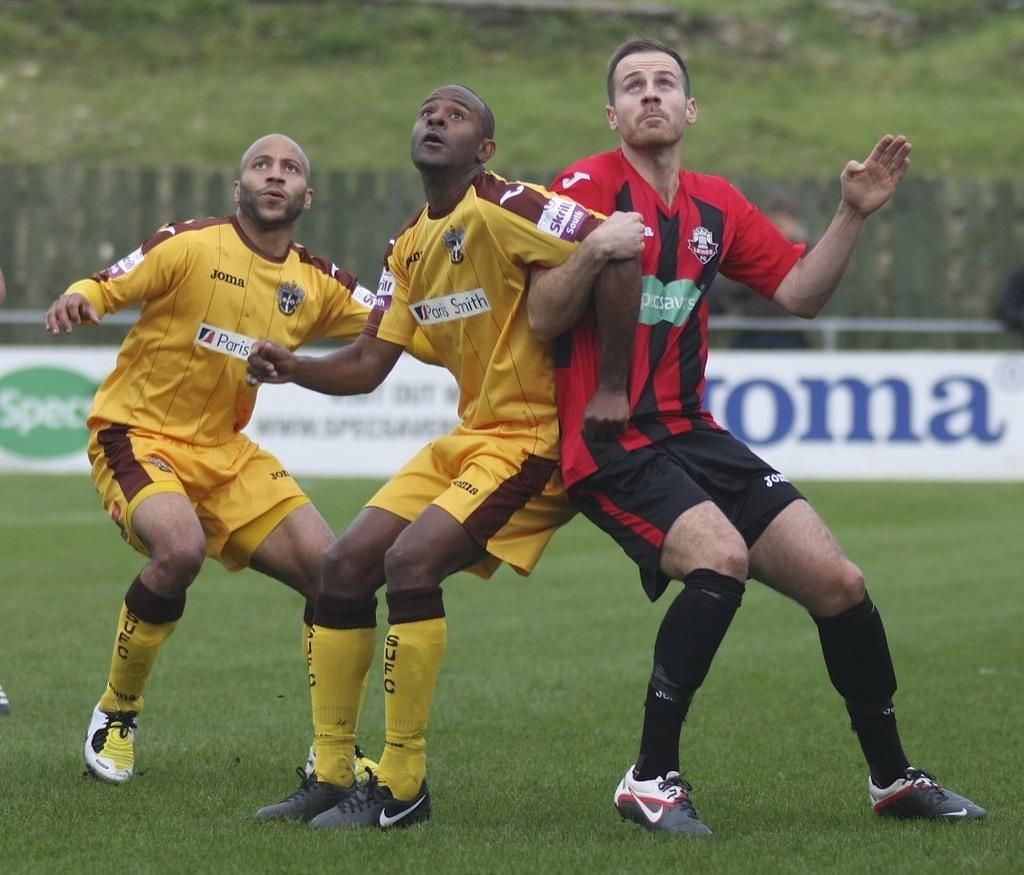<image>
Present a compact description of the photo's key features. Three football players, two in yellow uniforms and one in red with the SpecSavers logo on the front. 